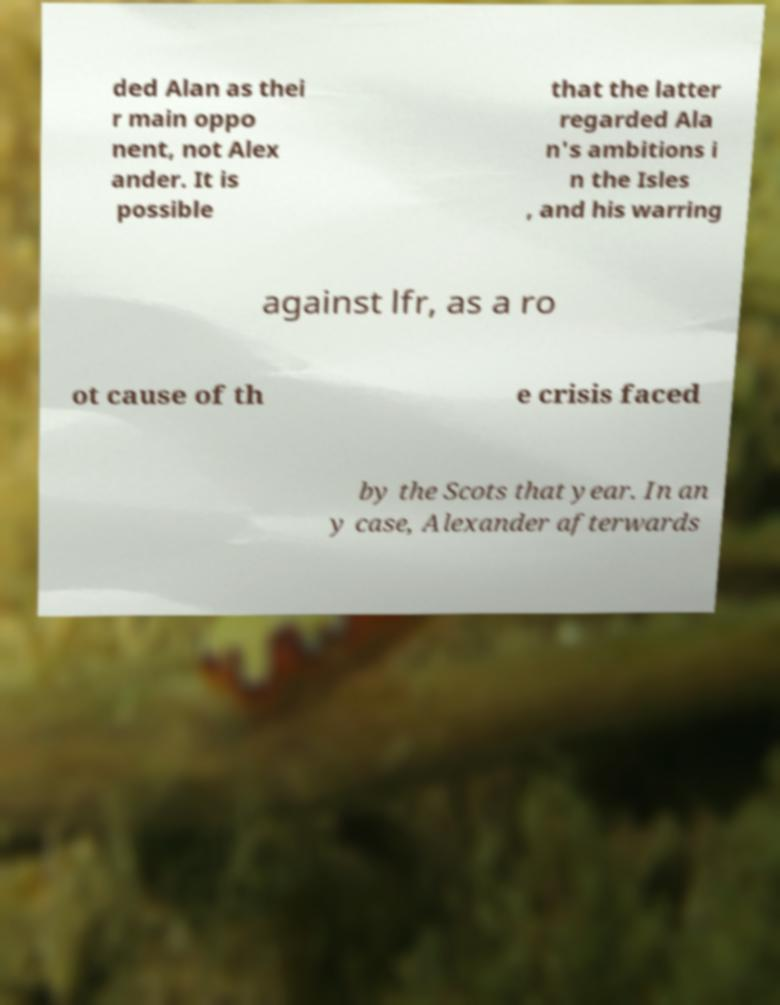Please read and relay the text visible in this image. What does it say? ded Alan as thei r main oppo nent, not Alex ander. It is possible that the latter regarded Ala n's ambitions i n the Isles , and his warring against lfr, as a ro ot cause of th e crisis faced by the Scots that year. In an y case, Alexander afterwards 